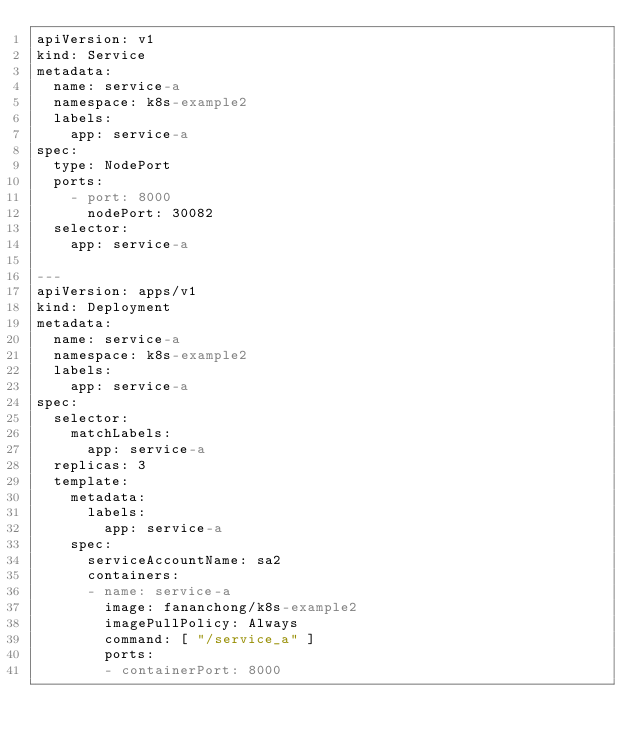Convert code to text. <code><loc_0><loc_0><loc_500><loc_500><_YAML_>apiVersion: v1
kind: Service
metadata:
  name: service-a
  namespace: k8s-example2
  labels:
    app: service-a
spec:
  type: NodePort
  ports:
    - port: 8000
      nodePort: 30082
  selector:
    app: service-a

---
apiVersion: apps/v1
kind: Deployment
metadata:
  name: service-a
  namespace: k8s-example2
  labels:
    app: service-a
spec:
  selector:
    matchLabels:
      app: service-a
  replicas: 3
  template:
    metadata:
      labels:
        app: service-a
    spec:
      serviceAccountName: sa2
      containers:
      - name: service-a
        image: fananchong/k8s-example2
        imagePullPolicy: Always
        command: [ "/service_a" ]
        ports:
        - containerPort: 8000


</code> 